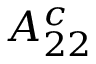Convert formula to latex. <formula><loc_0><loc_0><loc_500><loc_500>A _ { 2 2 } ^ { c }</formula> 